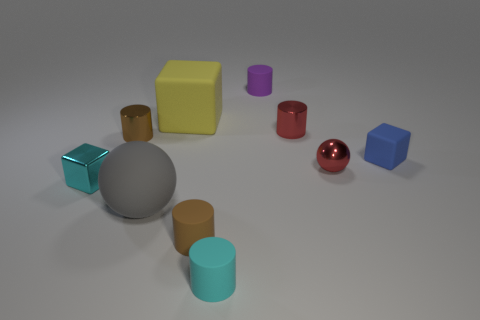Subtract all tiny red cylinders. How many cylinders are left? 4 Subtract all blue blocks. How many blocks are left? 2 Subtract all blue balls. How many brown cylinders are left? 2 Subtract 1 balls. How many balls are left? 1 Subtract all blocks. How many objects are left? 7 Add 6 blue things. How many blue things exist? 7 Subtract 0 green cubes. How many objects are left? 10 Subtract all purple cubes. Subtract all cyan cylinders. How many cubes are left? 3 Subtract all tiny purple metal cylinders. Subtract all small blue rubber things. How many objects are left? 9 Add 1 matte things. How many matte things are left? 7 